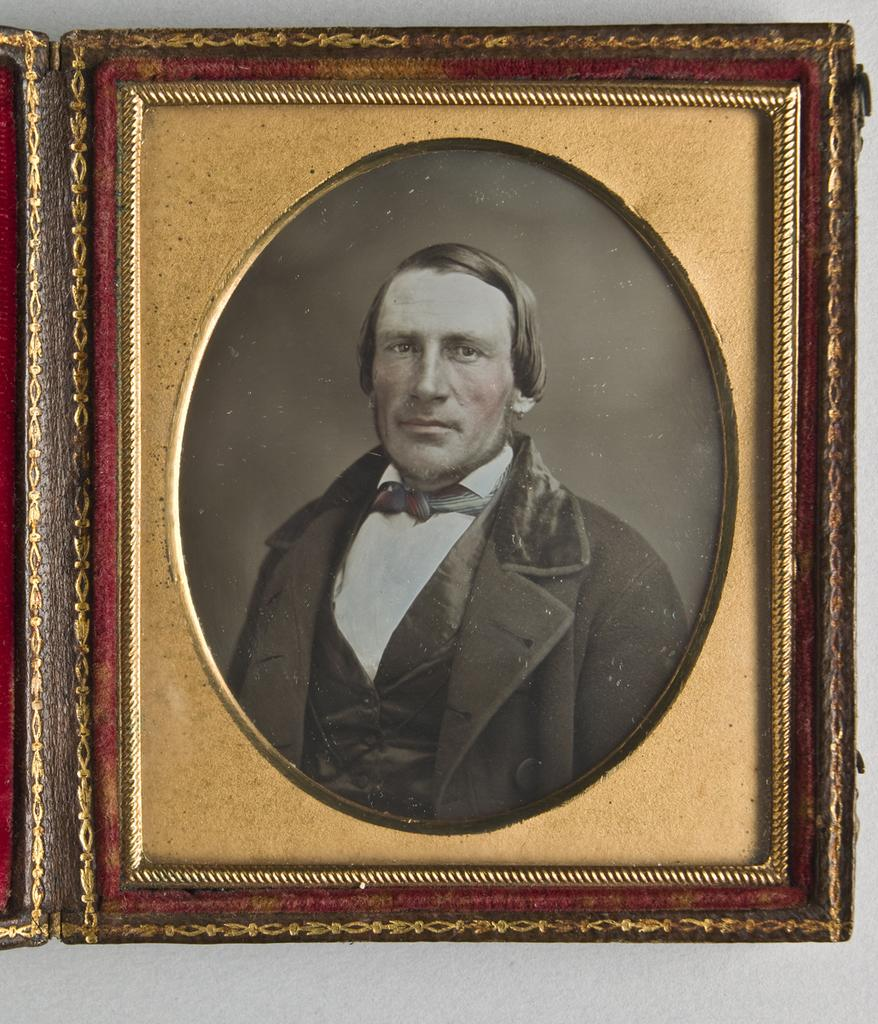What is the main object in the center of the image? There is a picture frame in the center of the image. Where is the picture frame located? The picture frame is hanging on a wall. What can be seen inside the picture frame? The picture frame contains a picture of a person. What is the person in the picture wearing? The person in the picture is wearing a suit. How many roses can be seen in the picture frame? There are no roses present in the image, as the picture frame contains a picture of a person wearing a suit. What type of badge is the person wearing in the image? There is no badge visible in the image; the person is wearing a suit. 